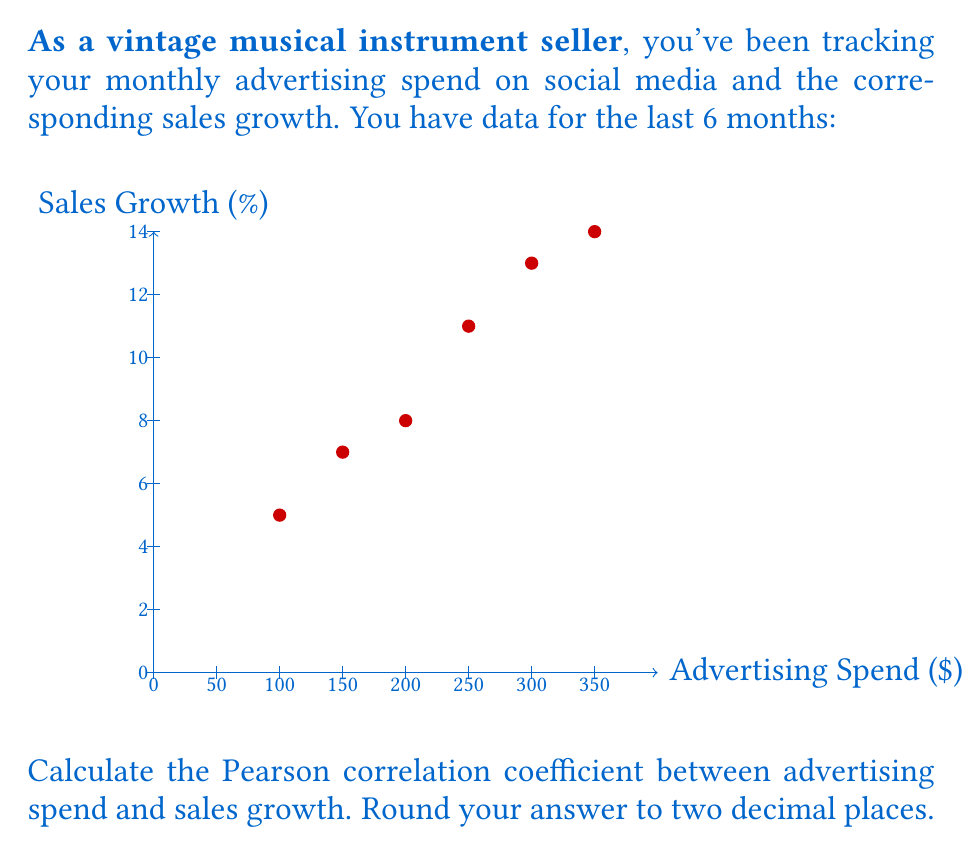Can you answer this question? To calculate the Pearson correlation coefficient (r), we'll use the formula:

$$ r = \frac{n\sum xy - \sum x \sum y}{\sqrt{[n\sum x^2 - (\sum x)^2][n\sum y^2 - (\sum y)^2]}} $$

Where:
n = number of data points
x = advertising spend
y = sales growth

Step 1: Calculate the necessary sums:
n = 6
$\sum x = 100 + 150 + 200 + 250 + 300 + 350 = 1350$
$\sum y = 5 + 7 + 8 + 11 + 13 + 14 = 58$
$\sum xy = (100 \times 5) + (150 \times 7) + (200 \times 8) + (250 \times 11) + (300 \times 13) + (350 \times 14) = 14,650$
$\sum x^2 = 100^2 + 150^2 + 200^2 + 250^2 + 300^2 + 350^2 = 367,500$
$\sum y^2 = 5^2 + 7^2 + 8^2 + 11^2 + 13^2 + 14^2 = 618$

Step 2: Apply the formula:

$$ r = \frac{6(14,650) - (1350)(58)}{\sqrt{[6(367,500) - 1350^2][6(618) - 58^2]}} $$

Step 3: Simplify:

$$ r = \frac{87,900 - 78,300}{\sqrt{(2,205,000 - 1,822,500)(3,708 - 3,364)}} $$

$$ r = \frac{9,600}{\sqrt{(382,500)(344)}} $$

$$ r = \frac{9,600}{\sqrt{131,580,000}} $$

$$ r = \frac{9,600}{11,470.83} $$

$$ r \approx 0.8369 $$

Step 4: Round to two decimal places:

$$ r \approx 0.84 $$
Answer: 0.84 